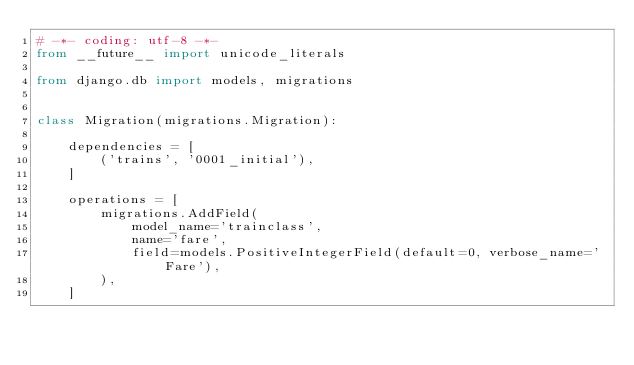Convert code to text. <code><loc_0><loc_0><loc_500><loc_500><_Python_># -*- coding: utf-8 -*-
from __future__ import unicode_literals

from django.db import models, migrations


class Migration(migrations.Migration):

    dependencies = [
        ('trains', '0001_initial'),
    ]

    operations = [
        migrations.AddField(
            model_name='trainclass',
            name='fare',
            field=models.PositiveIntegerField(default=0, verbose_name='Fare'),
        ),
    ]
</code> 